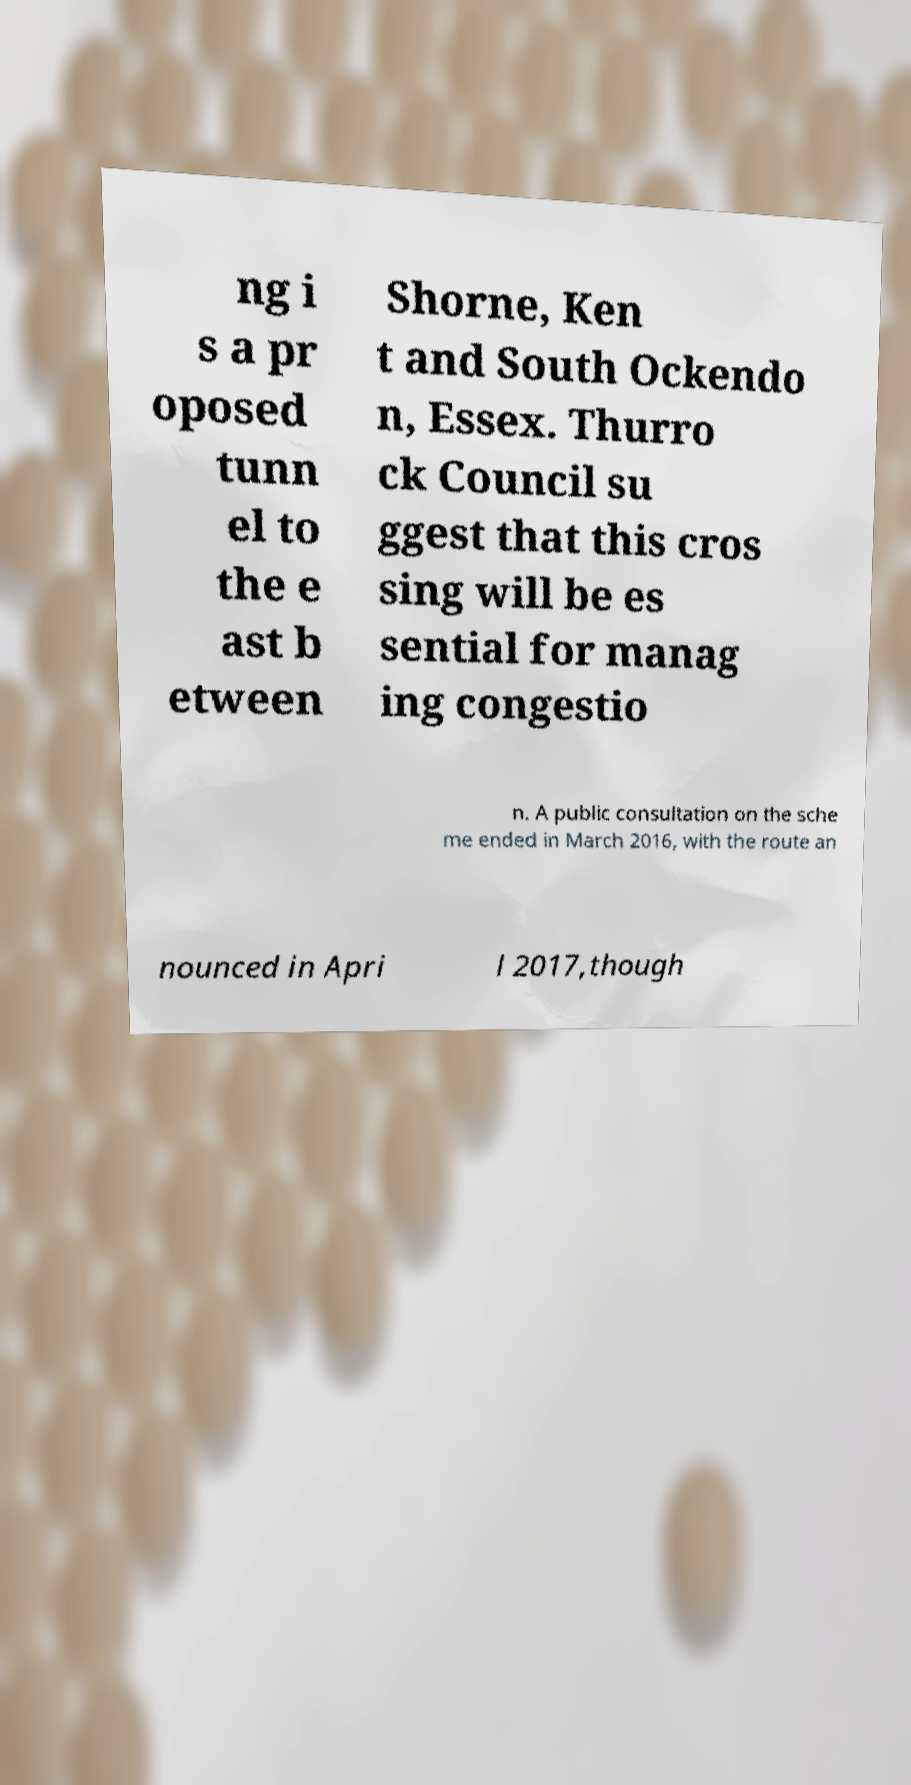Please identify and transcribe the text found in this image. ng i s a pr oposed tunn el to the e ast b etween Shorne, Ken t and South Ockendo n, Essex. Thurro ck Council su ggest that this cros sing will be es sential for manag ing congestio n. A public consultation on the sche me ended in March 2016, with the route an nounced in Apri l 2017,though 